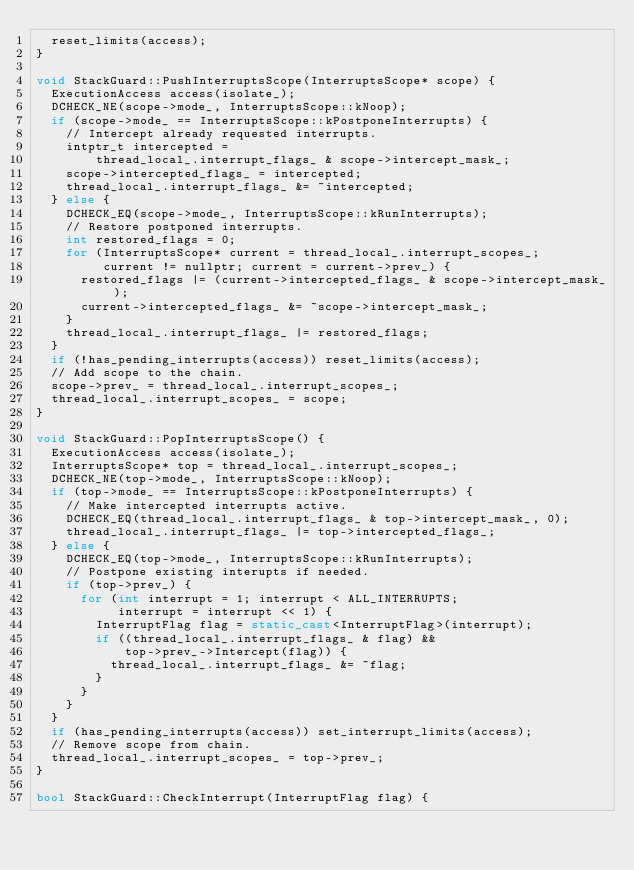Convert code to text. <code><loc_0><loc_0><loc_500><loc_500><_C++_>  reset_limits(access);
}

void StackGuard::PushInterruptsScope(InterruptsScope* scope) {
  ExecutionAccess access(isolate_);
  DCHECK_NE(scope->mode_, InterruptsScope::kNoop);
  if (scope->mode_ == InterruptsScope::kPostponeInterrupts) {
    // Intercept already requested interrupts.
    intptr_t intercepted =
        thread_local_.interrupt_flags_ & scope->intercept_mask_;
    scope->intercepted_flags_ = intercepted;
    thread_local_.interrupt_flags_ &= ~intercepted;
  } else {
    DCHECK_EQ(scope->mode_, InterruptsScope::kRunInterrupts);
    // Restore postponed interrupts.
    int restored_flags = 0;
    for (InterruptsScope* current = thread_local_.interrupt_scopes_;
         current != nullptr; current = current->prev_) {
      restored_flags |= (current->intercepted_flags_ & scope->intercept_mask_);
      current->intercepted_flags_ &= ~scope->intercept_mask_;
    }
    thread_local_.interrupt_flags_ |= restored_flags;
  }
  if (!has_pending_interrupts(access)) reset_limits(access);
  // Add scope to the chain.
  scope->prev_ = thread_local_.interrupt_scopes_;
  thread_local_.interrupt_scopes_ = scope;
}

void StackGuard::PopInterruptsScope() {
  ExecutionAccess access(isolate_);
  InterruptsScope* top = thread_local_.interrupt_scopes_;
  DCHECK_NE(top->mode_, InterruptsScope::kNoop);
  if (top->mode_ == InterruptsScope::kPostponeInterrupts) {
    // Make intercepted interrupts active.
    DCHECK_EQ(thread_local_.interrupt_flags_ & top->intercept_mask_, 0);
    thread_local_.interrupt_flags_ |= top->intercepted_flags_;
  } else {
    DCHECK_EQ(top->mode_, InterruptsScope::kRunInterrupts);
    // Postpone existing interupts if needed.
    if (top->prev_) {
      for (int interrupt = 1; interrupt < ALL_INTERRUPTS;
           interrupt = interrupt << 1) {
        InterruptFlag flag = static_cast<InterruptFlag>(interrupt);
        if ((thread_local_.interrupt_flags_ & flag) &&
            top->prev_->Intercept(flag)) {
          thread_local_.interrupt_flags_ &= ~flag;
        }
      }
    }
  }
  if (has_pending_interrupts(access)) set_interrupt_limits(access);
  // Remove scope from chain.
  thread_local_.interrupt_scopes_ = top->prev_;
}

bool StackGuard::CheckInterrupt(InterruptFlag flag) {</code> 